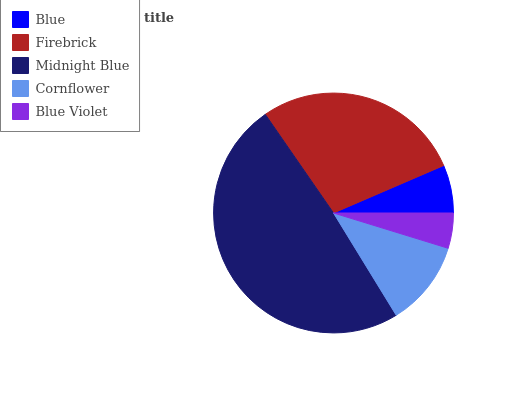Is Blue Violet the minimum?
Answer yes or no. Yes. Is Midnight Blue the maximum?
Answer yes or no. Yes. Is Firebrick the minimum?
Answer yes or no. No. Is Firebrick the maximum?
Answer yes or no. No. Is Firebrick greater than Blue?
Answer yes or no. Yes. Is Blue less than Firebrick?
Answer yes or no. Yes. Is Blue greater than Firebrick?
Answer yes or no. No. Is Firebrick less than Blue?
Answer yes or no. No. Is Cornflower the high median?
Answer yes or no. Yes. Is Cornflower the low median?
Answer yes or no. Yes. Is Blue Violet the high median?
Answer yes or no. No. Is Blue the low median?
Answer yes or no. No. 